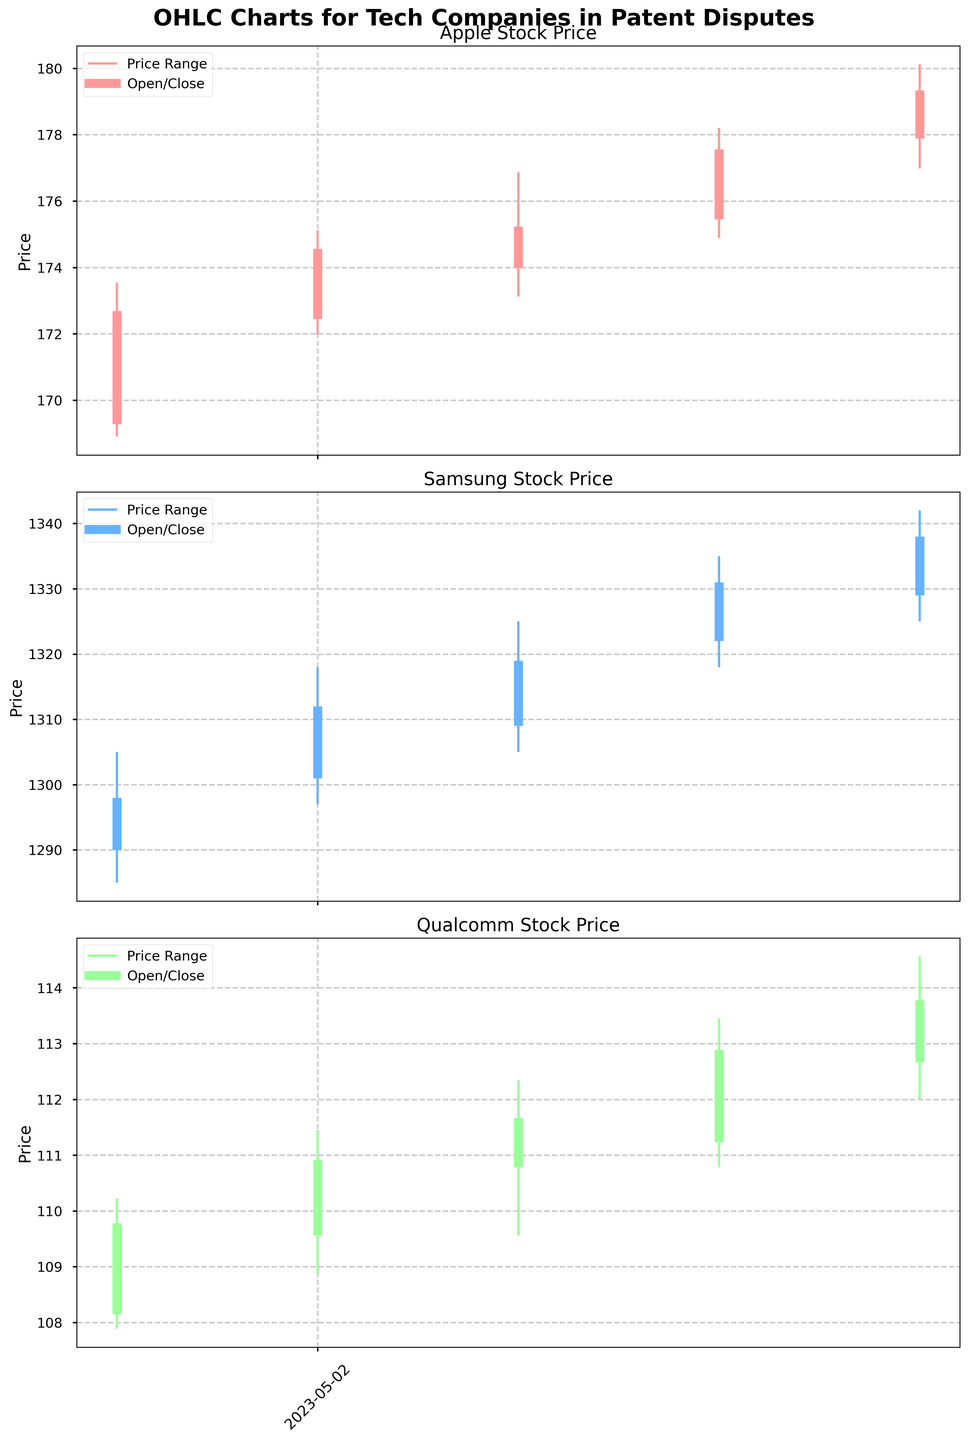Describe the general trend of Apple's stock price over the given dates Examine the OHLC chart for Apple. Notice that both the opening and closing prices trend upward from May 1st to May 5th with small fluctuations. This indicates a general upward trend.
Answer: Upward trend How does Samsung's price range on May 3rd compare to May 4th? Examine the length of the vertical lines representing price ranges. On May 3rd, Samsung's range is between 1305 and 1325, a 20-unit range. On May 4th, it's between 1318 and 1335, a 17-unit range.
Answer: May 3rd is wider Which company shows the highest closing price on May 5th? Look at the closing prices for Apple, Samsung, and Qualcomm on May 5th. Apple's closing price is 179.34, Samsung's is 1338, and Qualcomm's is 113.78. Apple has the highest closing price.
Answer: Apple Which day did Qualcomm experience the largest daily price range? Check the vertical lines for Qualcomm to find the longest one. On May 5th, Qualcomm's price range is from 112.01 to 114.56, a range of 2.55 units. This is the largest daily range for Qualcomm.
Answer: May 5th What is the average closing price of Samsung over the 5 days? Sum the closing prices of Samsung from May 1st to May 5th (1298 + 1312 + 1319 + 1331 + 1338) and divide by 5. (1298 + 1312 + 1319 + 1331 + 1338) / 5 = 1319.6
Answer: 1319.6 Which day did Apple experience the highest daily high price? Check the highest points on the vertical lines for Apple. On May 5th, the high is at 180.12, which is the highest among all dates.
Answer: May 5th Compare the opening prices of Apple and Samsung on May 1st. Which one is higher? Look at the opening prices on May 1st: Apple opens at 169.28 and Samsung opens at 1290.00. Clearly, Samsung's opening price is higher.
Answer: Samsung What is the difference between the closing and opening prices for Qualcomm on May 4th? Check the opening and closing prices for Qualcomm on May 4th: Opening at 111.23 and closing at 112.89. The difference is 112.89 - 111.23 = 1.66
Answer: 1.66 How does the price range (high - low) of Qualcomm on May 2nd compare to May 3rd? On May 2nd, Qualcomm's high is 111.45 and low is 108.87, resulting in a range of 2.58. On May 3rd, the high is 112.34 and the low is 109.56, resulting in a range of 2.78. The range on May 3rd is wider.
Answer: May 3rd is wider Which company had the smallest price range on any single day within the period? Compare the vertical line lengths for the smallest range. Samsung on May 1st had a range of 1285 to 1305, a 20-unit range. It’s the smallest among the given data.
Answer: Samsung on May 1st 